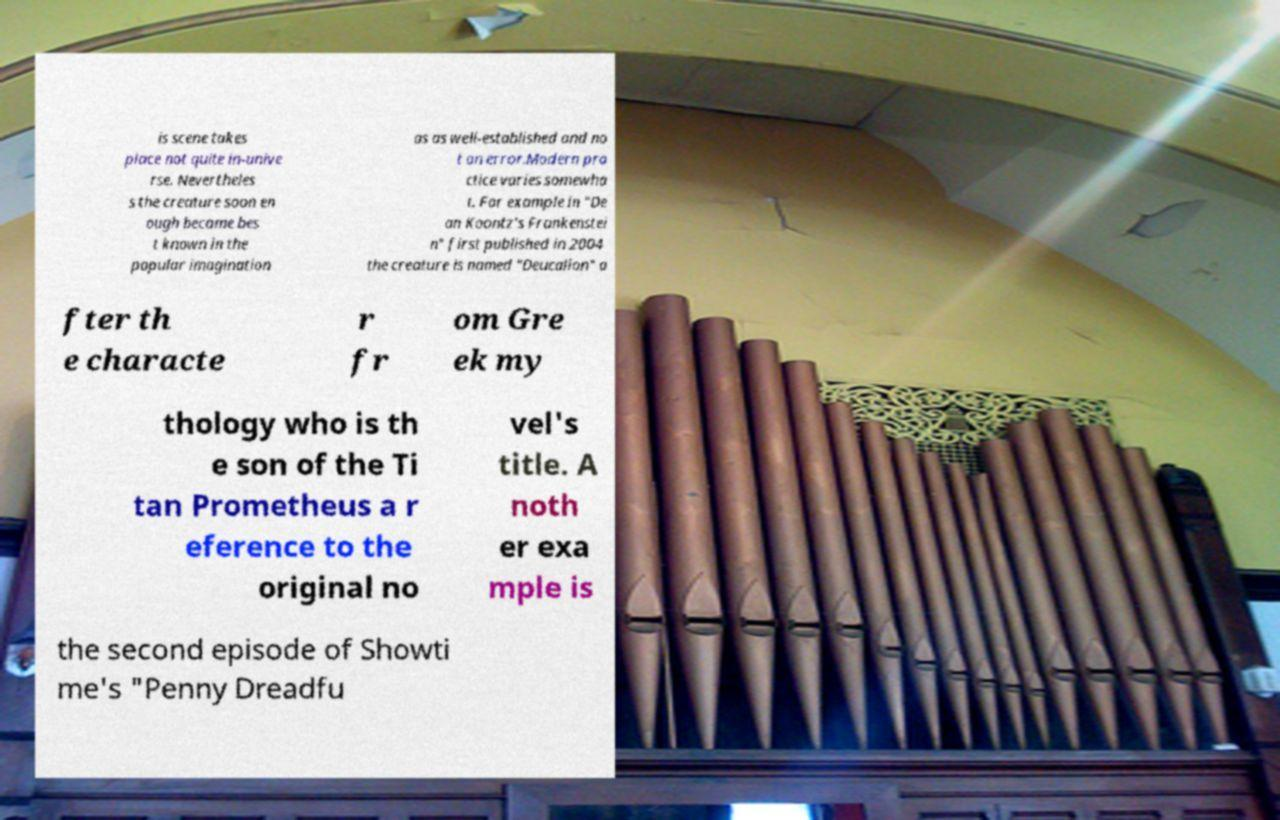For documentation purposes, I need the text within this image transcribed. Could you provide that? is scene takes place not quite in-unive rse. Nevertheles s the creature soon en ough became bes t known in the popular imagination as as well-established and no t an error.Modern pra ctice varies somewha t. For example in "De an Koontz's Frankenstei n" first published in 2004 the creature is named "Deucalion" a fter th e characte r fr om Gre ek my thology who is th e son of the Ti tan Prometheus a r eference to the original no vel's title. A noth er exa mple is the second episode of Showti me's "Penny Dreadfu 